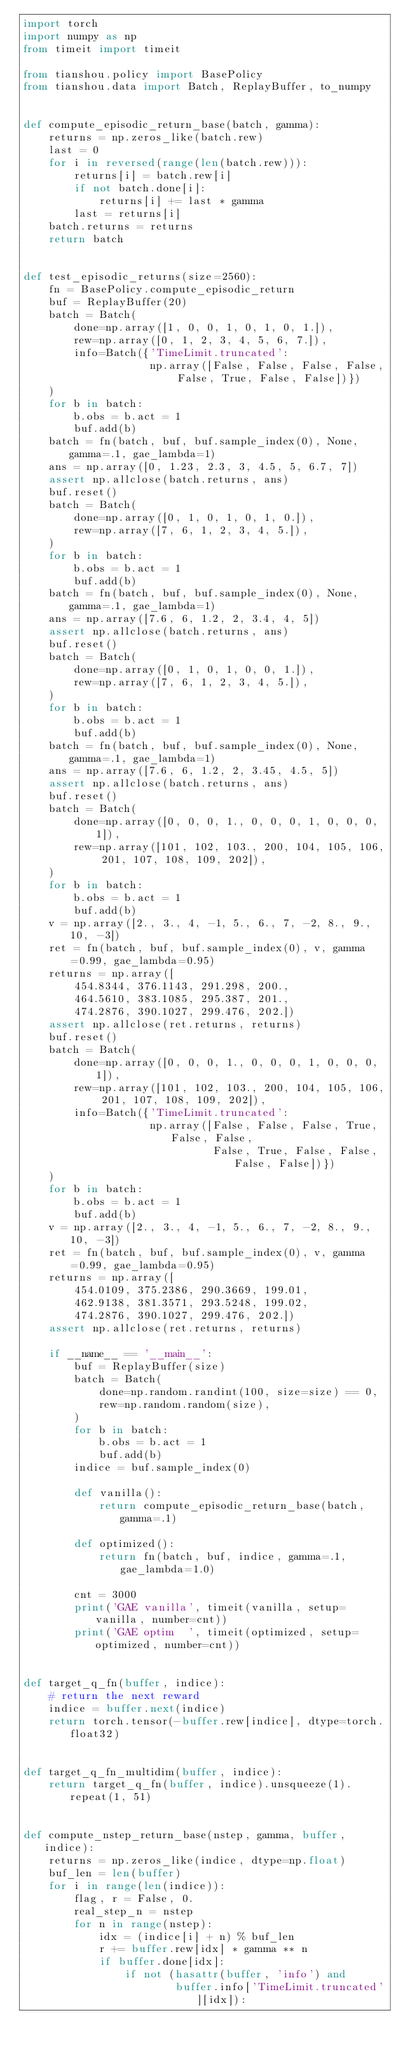<code> <loc_0><loc_0><loc_500><loc_500><_Python_>import torch
import numpy as np
from timeit import timeit

from tianshou.policy import BasePolicy
from tianshou.data import Batch, ReplayBuffer, to_numpy


def compute_episodic_return_base(batch, gamma):
    returns = np.zeros_like(batch.rew)
    last = 0
    for i in reversed(range(len(batch.rew))):
        returns[i] = batch.rew[i]
        if not batch.done[i]:
            returns[i] += last * gamma
        last = returns[i]
    batch.returns = returns
    return batch


def test_episodic_returns(size=2560):
    fn = BasePolicy.compute_episodic_return
    buf = ReplayBuffer(20)
    batch = Batch(
        done=np.array([1, 0, 0, 1, 0, 1, 0, 1.]),
        rew=np.array([0, 1, 2, 3, 4, 5, 6, 7.]),
        info=Batch({'TimeLimit.truncated':
                    np.array([False, False, False, False, False, True, False, False])})
    )
    for b in batch:
        b.obs = b.act = 1
        buf.add(b)
    batch = fn(batch, buf, buf.sample_index(0), None, gamma=.1, gae_lambda=1)
    ans = np.array([0, 1.23, 2.3, 3, 4.5, 5, 6.7, 7])
    assert np.allclose(batch.returns, ans)
    buf.reset()
    batch = Batch(
        done=np.array([0, 1, 0, 1, 0, 1, 0.]),
        rew=np.array([7, 6, 1, 2, 3, 4, 5.]),
    )
    for b in batch:
        b.obs = b.act = 1
        buf.add(b)
    batch = fn(batch, buf, buf.sample_index(0), None, gamma=.1, gae_lambda=1)
    ans = np.array([7.6, 6, 1.2, 2, 3.4, 4, 5])
    assert np.allclose(batch.returns, ans)
    buf.reset()
    batch = Batch(
        done=np.array([0, 1, 0, 1, 0, 0, 1.]),
        rew=np.array([7, 6, 1, 2, 3, 4, 5.]),
    )
    for b in batch:
        b.obs = b.act = 1
        buf.add(b)
    batch = fn(batch, buf, buf.sample_index(0), None, gamma=.1, gae_lambda=1)
    ans = np.array([7.6, 6, 1.2, 2, 3.45, 4.5, 5])
    assert np.allclose(batch.returns, ans)
    buf.reset()
    batch = Batch(
        done=np.array([0, 0, 0, 1., 0, 0, 0, 1, 0, 0, 0, 1]),
        rew=np.array([101, 102, 103., 200, 104, 105, 106, 201, 107, 108, 109, 202]),
    )
    for b in batch:
        b.obs = b.act = 1
        buf.add(b)
    v = np.array([2., 3., 4, -1, 5., 6., 7, -2, 8., 9., 10, -3])
    ret = fn(batch, buf, buf.sample_index(0), v, gamma=0.99, gae_lambda=0.95)
    returns = np.array([
        454.8344, 376.1143, 291.298, 200.,
        464.5610, 383.1085, 295.387, 201.,
        474.2876, 390.1027, 299.476, 202.])
    assert np.allclose(ret.returns, returns)
    buf.reset()
    batch = Batch(
        done=np.array([0, 0, 0, 1., 0, 0, 0, 1, 0, 0, 0, 1]),
        rew=np.array([101, 102, 103., 200, 104, 105, 106, 201, 107, 108, 109, 202]),
        info=Batch({'TimeLimit.truncated':
                    np.array([False, False, False, True, False, False,
                              False, True, False, False, False, False])})
    )
    for b in batch:
        b.obs = b.act = 1
        buf.add(b)
    v = np.array([2., 3., 4, -1, 5., 6., 7, -2, 8., 9., 10, -3])
    ret = fn(batch, buf, buf.sample_index(0), v, gamma=0.99, gae_lambda=0.95)
    returns = np.array([
        454.0109, 375.2386, 290.3669, 199.01,
        462.9138, 381.3571, 293.5248, 199.02,
        474.2876, 390.1027, 299.476, 202.])
    assert np.allclose(ret.returns, returns)

    if __name__ == '__main__':
        buf = ReplayBuffer(size)
        batch = Batch(
            done=np.random.randint(100, size=size) == 0,
            rew=np.random.random(size),
        )
        for b in batch:
            b.obs = b.act = 1
            buf.add(b)
        indice = buf.sample_index(0)

        def vanilla():
            return compute_episodic_return_base(batch, gamma=.1)

        def optimized():
            return fn(batch, buf, indice, gamma=.1, gae_lambda=1.0)

        cnt = 3000
        print('GAE vanilla', timeit(vanilla, setup=vanilla, number=cnt))
        print('GAE optim  ', timeit(optimized, setup=optimized, number=cnt))


def target_q_fn(buffer, indice):
    # return the next reward
    indice = buffer.next(indice)
    return torch.tensor(-buffer.rew[indice], dtype=torch.float32)


def target_q_fn_multidim(buffer, indice):
    return target_q_fn(buffer, indice).unsqueeze(1).repeat(1, 51)


def compute_nstep_return_base(nstep, gamma, buffer, indice):
    returns = np.zeros_like(indice, dtype=np.float)
    buf_len = len(buffer)
    for i in range(len(indice)):
        flag, r = False, 0.
        real_step_n = nstep
        for n in range(nstep):
            idx = (indice[i] + n) % buf_len
            r += buffer.rew[idx] * gamma ** n
            if buffer.done[idx]:
                if not (hasattr(buffer, 'info') and
                        buffer.info['TimeLimit.truncated'][idx]):</code> 